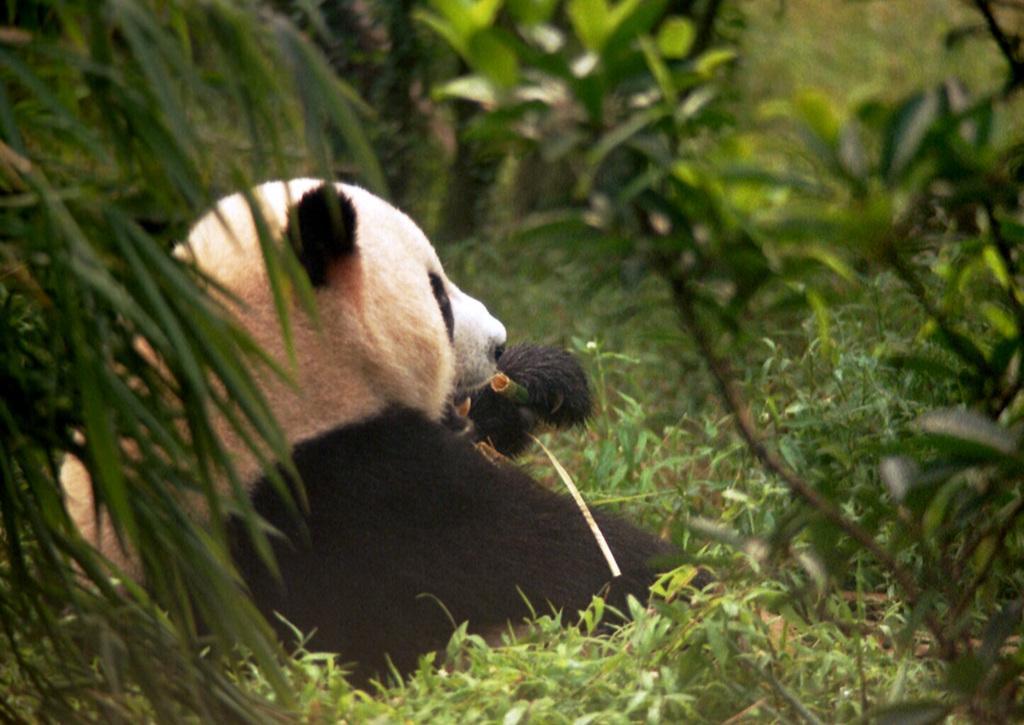Please provide a concise description of this image. In this picture we can see a panda and few plants. 